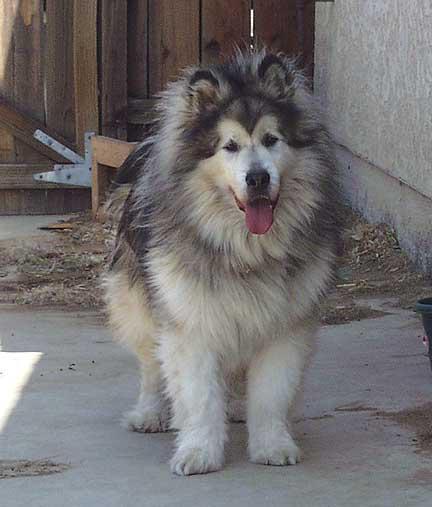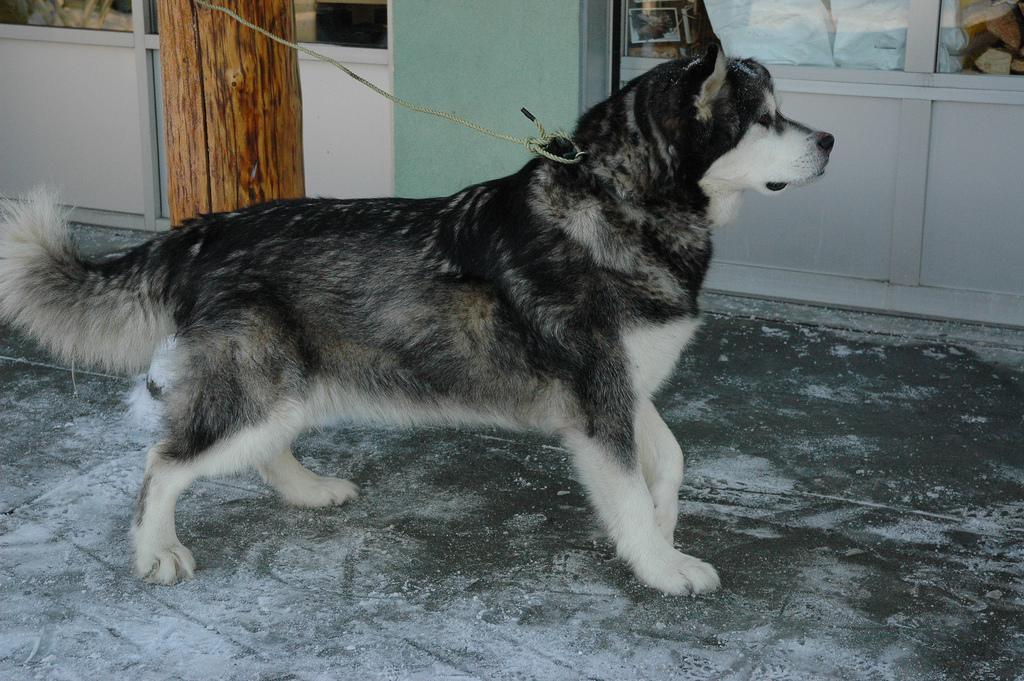The first image is the image on the left, the second image is the image on the right. For the images shown, is this caption "In the image to the right, a human stands near the dogs." true? Answer yes or no. No. The first image is the image on the left, the second image is the image on the right. Considering the images on both sides, is "The left image features one standing open-mouthed dog, and the right image features one standing close-mouthed dog." valid? Answer yes or no. Yes. 